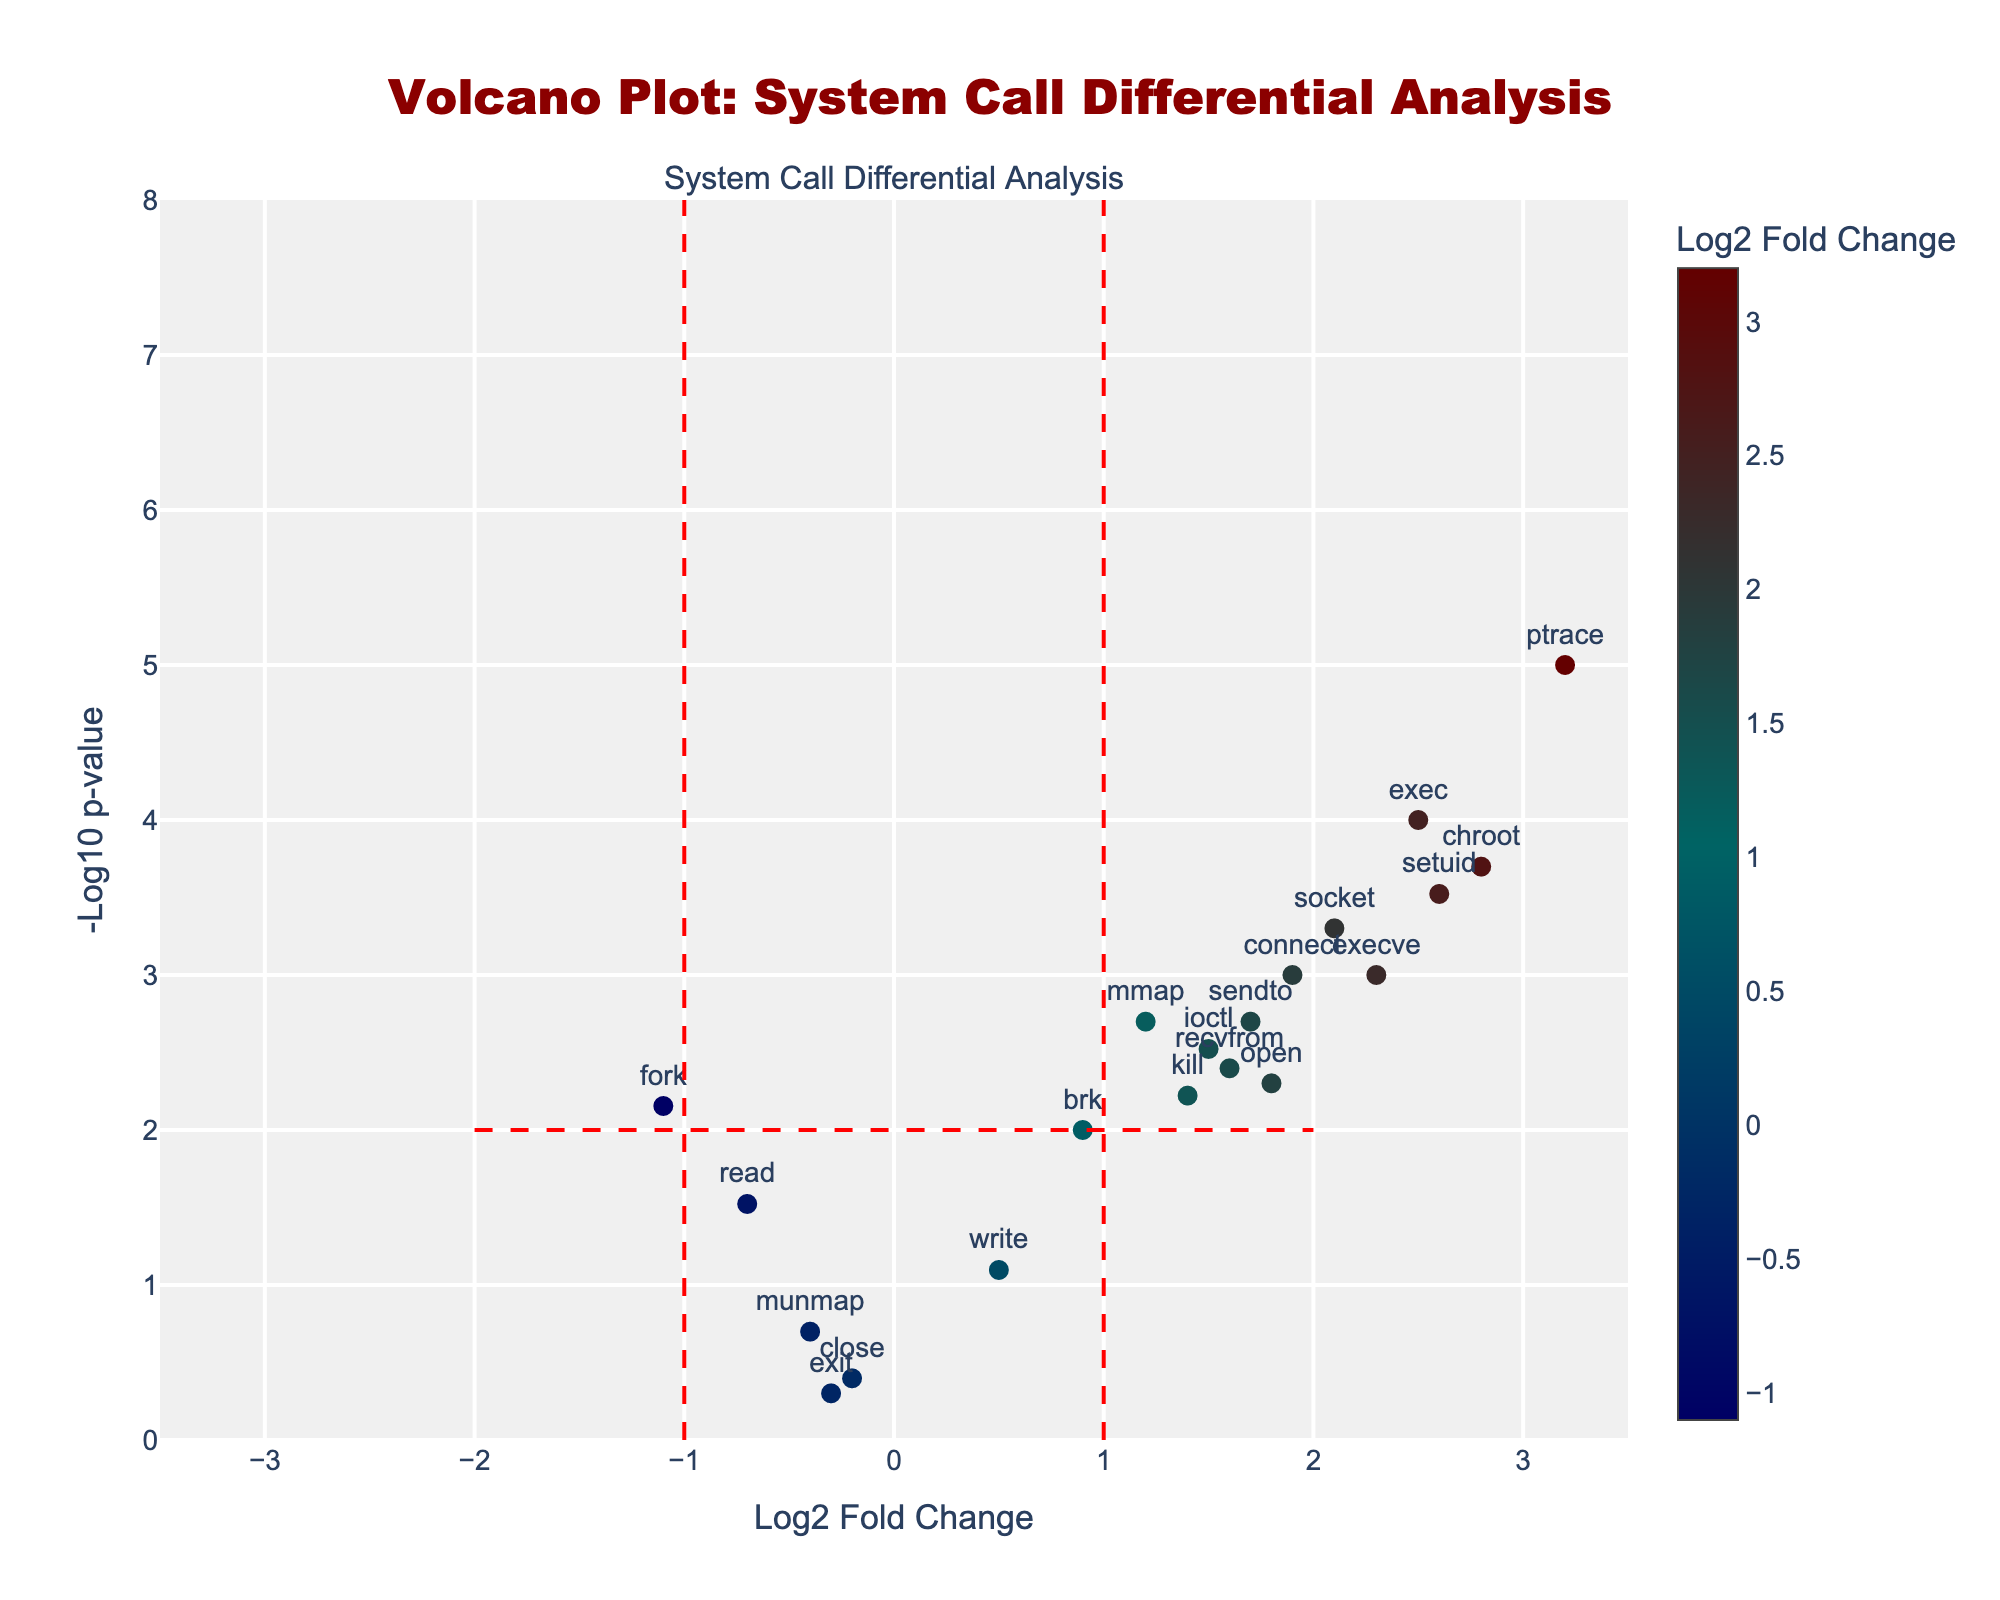How many system calls have a Log2 Fold Change greater than 1.5? To find this, we look at the x-axis for points to the right of 1.5. These include: exec, chroot, setuid, socket, connect, and ioctl, resulting in 6 system calls.
Answer: 6 What is the range of the -Log10 p-value axis? The y-axis labeled '-Log10 p-value' ranges from 0 to 8, as indicated by the axis ticks and limits.
Answer: 0 to 8 Which system call shows the highest statistical significance? The highest statistical significance corresponds to the point with the highest -Log10 p-value. This point is ptrace, as it is highest on the y-axis.
Answer: ptrace Are there any system calls with a negative Log2 Fold Change and a -Log10 p-value greater than 2? System calls with a negative Log2 Fold Change are to the left of the vertical line at 0. Fork is the only system call in this region above the horizontal line at 2.
Answer: Fork Which regions in the plot indicate a significant change in system call frequencies? The regions of significant change are identified by the lines at -Log10 p-value > 2 and Log2 Fold Change > 1 or < -1. The points in these regions indicate significant changes.
Answer: Regions outside the dashed lines How many system calls have a p-value less than 0.01? Since -Log10(0.01) = 2, we look for points above y=2. These include exec, ptrace, chroot, setuid, socket, execve, mmap, ioctl, connect, sendto. There are a total of 10 points.
Answer: 10 Which system call has the smallest p-value? The system call with the smallest p-value will be the highest on the y-axis. Ptrace is positioned at this highest point.
Answer: ptrace What can you infer about system calls with positive Log2 Fold Change values? Points to the right of the vertical line at x=0 (positive Log2 Fold Change) include calls like exec, ptrace, chroot, setuid, socket, connect, etc. These indicate higher frequencies in exploitable applications.
Answer: Higher in exploitable applications Which system call has the greatest positive Log2 Fold Change? The point farthest to the right on the x-axis indicates the greatest positive Log2 Fold Change. This point corresponds to ptrace.
Answer: ptrace How many system calls fall into the 'non-significant' category? Non-significant calls are within the bounds of -1 to 1 on the x-axis and below -Log10 p-value of 2 on the y-axis. These include read, write, close, munmap, brk, and exit. There are 6 such calls.
Answer: 6 